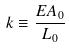<formula> <loc_0><loc_0><loc_500><loc_500>k \equiv \frac { E A _ { 0 } } { L _ { 0 } }</formula> 